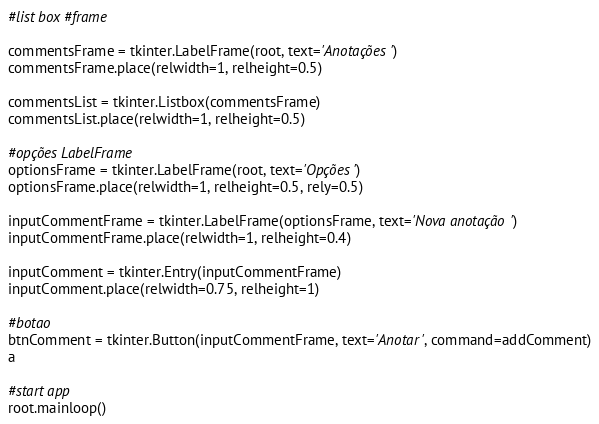<code> <loc_0><loc_0><loc_500><loc_500><_Python_>#list box #frame

commentsFrame = tkinter.LabelFrame(root, text='Anotações')
commentsFrame.place(relwidth=1, relheight=0.5)

commentsList = tkinter.Listbox(commentsFrame)
commentsList.place(relwidth=1, relheight=0.5)

#opções LabelFrame
optionsFrame = tkinter.LabelFrame(root, text='Opções')
optionsFrame.place(relwidth=1, relheight=0.5, rely=0.5)

inputCommentFrame = tkinter.LabelFrame(optionsFrame, text='Nova anotação')
inputCommentFrame.place(relwidth=1, relheight=0.4)

inputComment = tkinter.Entry(inputCommentFrame)
inputComment.place(relwidth=0.75, relheight=1)

#botao
btnComment = tkinter.Button(inputCommentFrame, text='Anotar', command=addComment)
a

#start app
root.mainloop()

</code> 